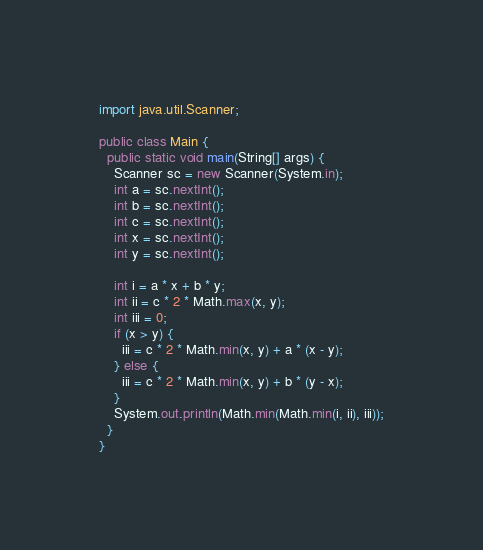<code> <loc_0><loc_0><loc_500><loc_500><_Java_>import java.util.Scanner;

public class Main {
  public static void main(String[] args) {
    Scanner sc = new Scanner(System.in);
    int a = sc.nextInt();
    int b = sc.nextInt();
    int c = sc.nextInt();
    int x = sc.nextInt();
    int y = sc.nextInt();

    int i = a * x + b * y;
    int ii = c * 2 * Math.max(x, y);
    int iii = 0;
    if (x > y) {
      iii = c * 2 * Math.min(x, y) + a * (x - y);
    } else {
      iii = c * 2 * Math.min(x, y) + b * (y - x);
    }
    System.out.println(Math.min(Math.min(i, ii), iii));
  }
}
</code> 